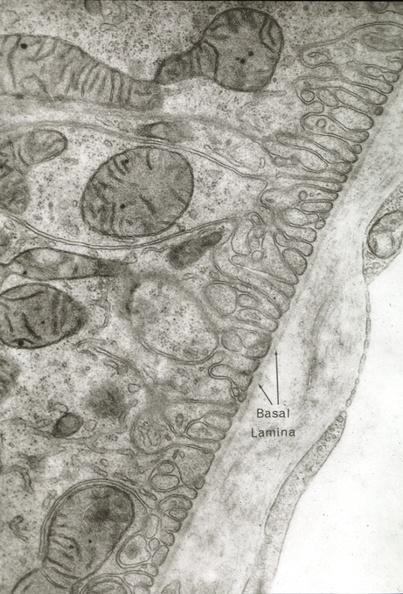s vasculature present?
Answer the question using a single word or phrase. Yes 